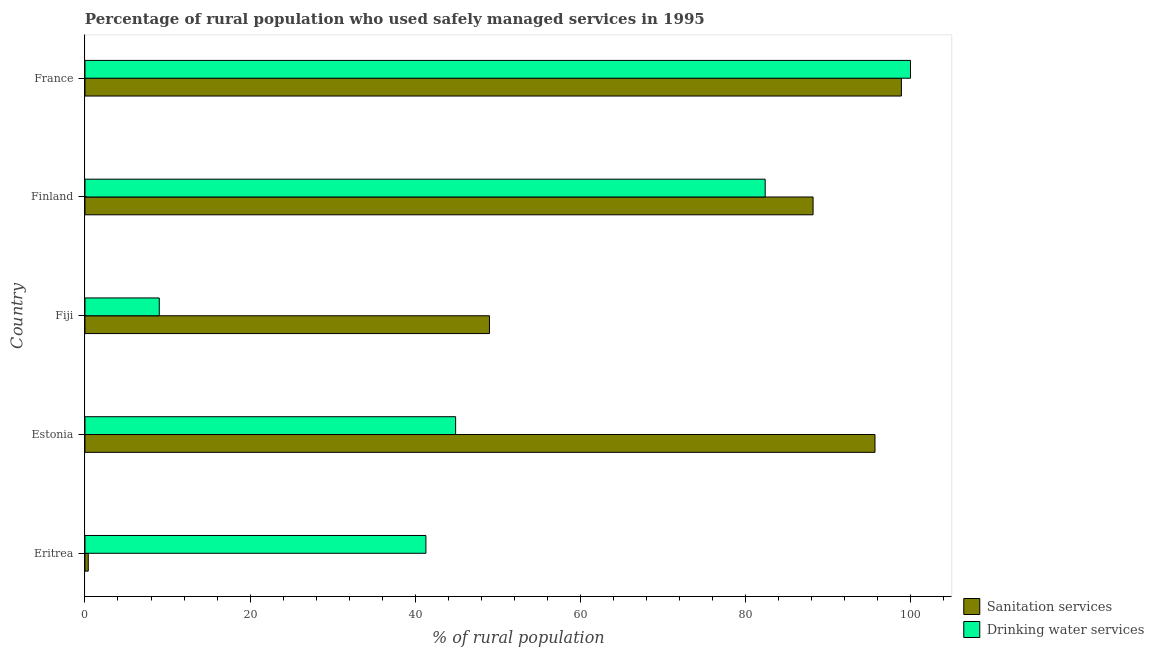How many different coloured bars are there?
Your response must be concise. 2. How many groups of bars are there?
Offer a terse response. 5. Are the number of bars per tick equal to the number of legend labels?
Offer a very short reply. Yes. What is the label of the 5th group of bars from the top?
Keep it short and to the point. Eritrea. What is the percentage of rural population who used drinking water services in Estonia?
Your answer should be very brief. 44.9. Across all countries, what is the maximum percentage of rural population who used sanitation services?
Offer a terse response. 98.9. Across all countries, what is the minimum percentage of rural population who used sanitation services?
Ensure brevity in your answer.  0.4. In which country was the percentage of rural population who used drinking water services maximum?
Offer a very short reply. France. In which country was the percentage of rural population who used drinking water services minimum?
Give a very brief answer. Fiji. What is the total percentage of rural population who used sanitation services in the graph?
Provide a short and direct response. 332.2. What is the difference between the percentage of rural population who used drinking water services in Eritrea and that in Finland?
Your answer should be very brief. -41.1. What is the difference between the percentage of rural population who used drinking water services in Fiji and the percentage of rural population who used sanitation services in France?
Give a very brief answer. -89.9. What is the average percentage of rural population who used sanitation services per country?
Offer a very short reply. 66.44. What is the difference between the percentage of rural population who used sanitation services and percentage of rural population who used drinking water services in Eritrea?
Provide a succinct answer. -40.9. What is the ratio of the percentage of rural population who used drinking water services in Estonia to that in Fiji?
Your response must be concise. 4.99. What is the difference between the highest and the lowest percentage of rural population who used drinking water services?
Give a very brief answer. 91. In how many countries, is the percentage of rural population who used sanitation services greater than the average percentage of rural population who used sanitation services taken over all countries?
Your response must be concise. 3. What does the 2nd bar from the top in France represents?
Make the answer very short. Sanitation services. What does the 1st bar from the bottom in Estonia represents?
Offer a terse response. Sanitation services. How many countries are there in the graph?
Offer a very short reply. 5. Are the values on the major ticks of X-axis written in scientific E-notation?
Make the answer very short. No. Does the graph contain any zero values?
Ensure brevity in your answer.  No. What is the title of the graph?
Your answer should be very brief. Percentage of rural population who used safely managed services in 1995. What is the label or title of the X-axis?
Provide a succinct answer. % of rural population. What is the label or title of the Y-axis?
Provide a short and direct response. Country. What is the % of rural population in Drinking water services in Eritrea?
Keep it short and to the point. 41.3. What is the % of rural population of Sanitation services in Estonia?
Keep it short and to the point. 95.7. What is the % of rural population of Drinking water services in Estonia?
Keep it short and to the point. 44.9. What is the % of rural population in Sanitation services in Fiji?
Your response must be concise. 49. What is the % of rural population of Sanitation services in Finland?
Provide a short and direct response. 88.2. What is the % of rural population in Drinking water services in Finland?
Your response must be concise. 82.4. What is the % of rural population of Sanitation services in France?
Your answer should be compact. 98.9. Across all countries, what is the maximum % of rural population of Sanitation services?
Give a very brief answer. 98.9. Across all countries, what is the minimum % of rural population of Sanitation services?
Offer a very short reply. 0.4. What is the total % of rural population of Sanitation services in the graph?
Provide a succinct answer. 332.2. What is the total % of rural population in Drinking water services in the graph?
Keep it short and to the point. 277.6. What is the difference between the % of rural population in Sanitation services in Eritrea and that in Estonia?
Make the answer very short. -95.3. What is the difference between the % of rural population in Sanitation services in Eritrea and that in Fiji?
Provide a succinct answer. -48.6. What is the difference between the % of rural population of Drinking water services in Eritrea and that in Fiji?
Your answer should be very brief. 32.3. What is the difference between the % of rural population of Sanitation services in Eritrea and that in Finland?
Ensure brevity in your answer.  -87.8. What is the difference between the % of rural population of Drinking water services in Eritrea and that in Finland?
Offer a terse response. -41.1. What is the difference between the % of rural population of Sanitation services in Eritrea and that in France?
Keep it short and to the point. -98.5. What is the difference between the % of rural population in Drinking water services in Eritrea and that in France?
Ensure brevity in your answer.  -58.7. What is the difference between the % of rural population in Sanitation services in Estonia and that in Fiji?
Keep it short and to the point. 46.7. What is the difference between the % of rural population of Drinking water services in Estonia and that in Fiji?
Your answer should be very brief. 35.9. What is the difference between the % of rural population of Sanitation services in Estonia and that in Finland?
Provide a succinct answer. 7.5. What is the difference between the % of rural population of Drinking water services in Estonia and that in Finland?
Offer a terse response. -37.5. What is the difference between the % of rural population in Sanitation services in Estonia and that in France?
Your answer should be very brief. -3.2. What is the difference between the % of rural population of Drinking water services in Estonia and that in France?
Your response must be concise. -55.1. What is the difference between the % of rural population of Sanitation services in Fiji and that in Finland?
Offer a terse response. -39.2. What is the difference between the % of rural population of Drinking water services in Fiji and that in Finland?
Keep it short and to the point. -73.4. What is the difference between the % of rural population in Sanitation services in Fiji and that in France?
Your answer should be very brief. -49.9. What is the difference between the % of rural population of Drinking water services in Fiji and that in France?
Give a very brief answer. -91. What is the difference between the % of rural population of Drinking water services in Finland and that in France?
Provide a short and direct response. -17.6. What is the difference between the % of rural population in Sanitation services in Eritrea and the % of rural population in Drinking water services in Estonia?
Provide a short and direct response. -44.5. What is the difference between the % of rural population in Sanitation services in Eritrea and the % of rural population in Drinking water services in Finland?
Ensure brevity in your answer.  -82. What is the difference between the % of rural population of Sanitation services in Eritrea and the % of rural population of Drinking water services in France?
Provide a succinct answer. -99.6. What is the difference between the % of rural population of Sanitation services in Estonia and the % of rural population of Drinking water services in Fiji?
Offer a terse response. 86.7. What is the difference between the % of rural population of Sanitation services in Estonia and the % of rural population of Drinking water services in France?
Provide a short and direct response. -4.3. What is the difference between the % of rural population in Sanitation services in Fiji and the % of rural population in Drinking water services in Finland?
Your response must be concise. -33.4. What is the difference between the % of rural population in Sanitation services in Fiji and the % of rural population in Drinking water services in France?
Provide a short and direct response. -51. What is the average % of rural population of Sanitation services per country?
Your answer should be very brief. 66.44. What is the average % of rural population of Drinking water services per country?
Make the answer very short. 55.52. What is the difference between the % of rural population in Sanitation services and % of rural population in Drinking water services in Eritrea?
Give a very brief answer. -40.9. What is the difference between the % of rural population of Sanitation services and % of rural population of Drinking water services in Estonia?
Your answer should be compact. 50.8. What is the difference between the % of rural population of Sanitation services and % of rural population of Drinking water services in Fiji?
Your answer should be very brief. 40. What is the ratio of the % of rural population in Sanitation services in Eritrea to that in Estonia?
Offer a very short reply. 0. What is the ratio of the % of rural population of Drinking water services in Eritrea to that in Estonia?
Provide a short and direct response. 0.92. What is the ratio of the % of rural population in Sanitation services in Eritrea to that in Fiji?
Provide a succinct answer. 0.01. What is the ratio of the % of rural population in Drinking water services in Eritrea to that in Fiji?
Your response must be concise. 4.59. What is the ratio of the % of rural population in Sanitation services in Eritrea to that in Finland?
Your answer should be compact. 0. What is the ratio of the % of rural population of Drinking water services in Eritrea to that in Finland?
Offer a terse response. 0.5. What is the ratio of the % of rural population in Sanitation services in Eritrea to that in France?
Ensure brevity in your answer.  0. What is the ratio of the % of rural population of Drinking water services in Eritrea to that in France?
Your answer should be compact. 0.41. What is the ratio of the % of rural population in Sanitation services in Estonia to that in Fiji?
Offer a terse response. 1.95. What is the ratio of the % of rural population of Drinking water services in Estonia to that in Fiji?
Provide a succinct answer. 4.99. What is the ratio of the % of rural population of Sanitation services in Estonia to that in Finland?
Your response must be concise. 1.08. What is the ratio of the % of rural population in Drinking water services in Estonia to that in Finland?
Give a very brief answer. 0.54. What is the ratio of the % of rural population of Sanitation services in Estonia to that in France?
Offer a terse response. 0.97. What is the ratio of the % of rural population of Drinking water services in Estonia to that in France?
Offer a terse response. 0.45. What is the ratio of the % of rural population of Sanitation services in Fiji to that in Finland?
Offer a terse response. 0.56. What is the ratio of the % of rural population in Drinking water services in Fiji to that in Finland?
Your answer should be compact. 0.11. What is the ratio of the % of rural population of Sanitation services in Fiji to that in France?
Provide a succinct answer. 0.5. What is the ratio of the % of rural population in Drinking water services in Fiji to that in France?
Your answer should be very brief. 0.09. What is the ratio of the % of rural population of Sanitation services in Finland to that in France?
Make the answer very short. 0.89. What is the ratio of the % of rural population of Drinking water services in Finland to that in France?
Give a very brief answer. 0.82. What is the difference between the highest and the second highest % of rural population of Drinking water services?
Provide a short and direct response. 17.6. What is the difference between the highest and the lowest % of rural population in Sanitation services?
Offer a terse response. 98.5. What is the difference between the highest and the lowest % of rural population in Drinking water services?
Provide a succinct answer. 91. 